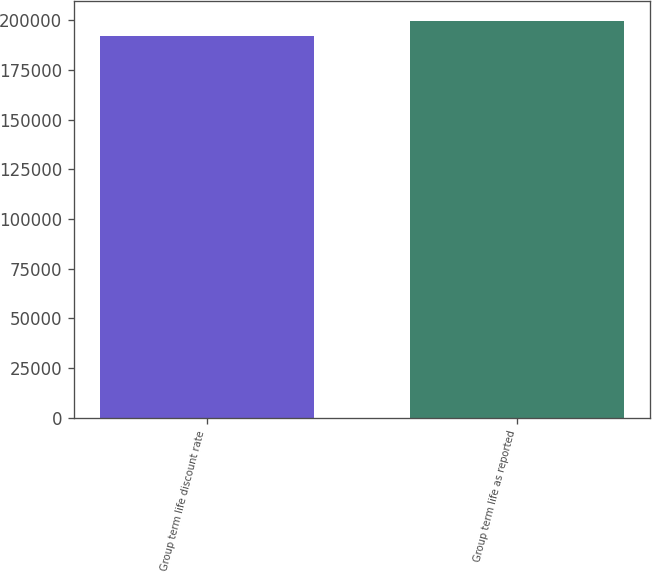<chart> <loc_0><loc_0><loc_500><loc_500><bar_chart><fcel>Group term life discount rate<fcel>Group term life as reported<nl><fcel>192122<fcel>199771<nl></chart> 